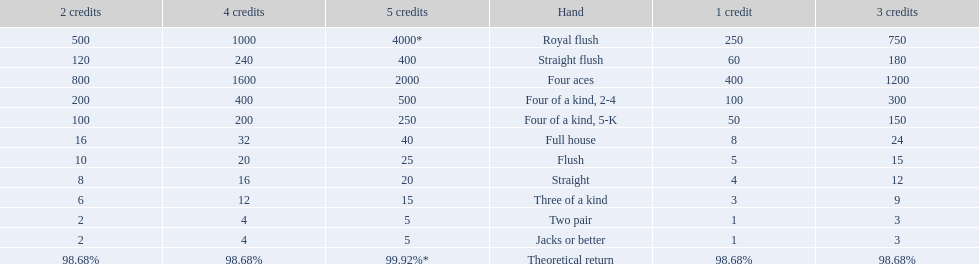Which hand is the third best hand in the card game super aces? Four aces. Which hand is the second best hand? Straight flush. Which hand had is the best hand? Royal flush. 